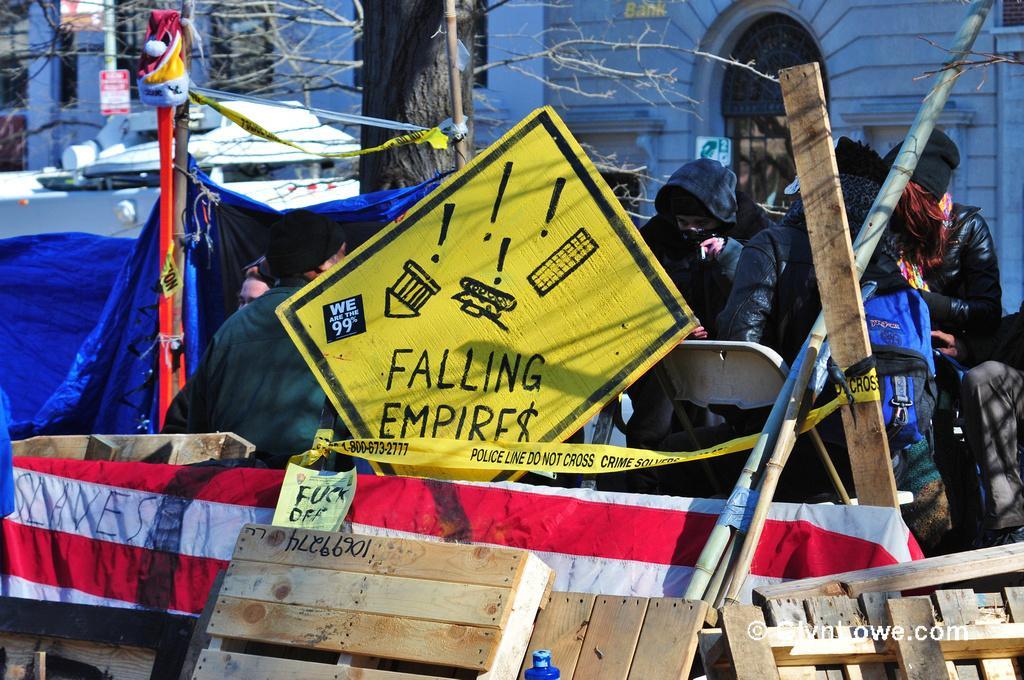In one or two sentences, can you explain what this image depicts? In this image in the front there are wooden objects and there are banners with some text written on it. In the center there are persons, there are cars, there are tents. In the background there is a building and there are trees and in the center there are poles. 